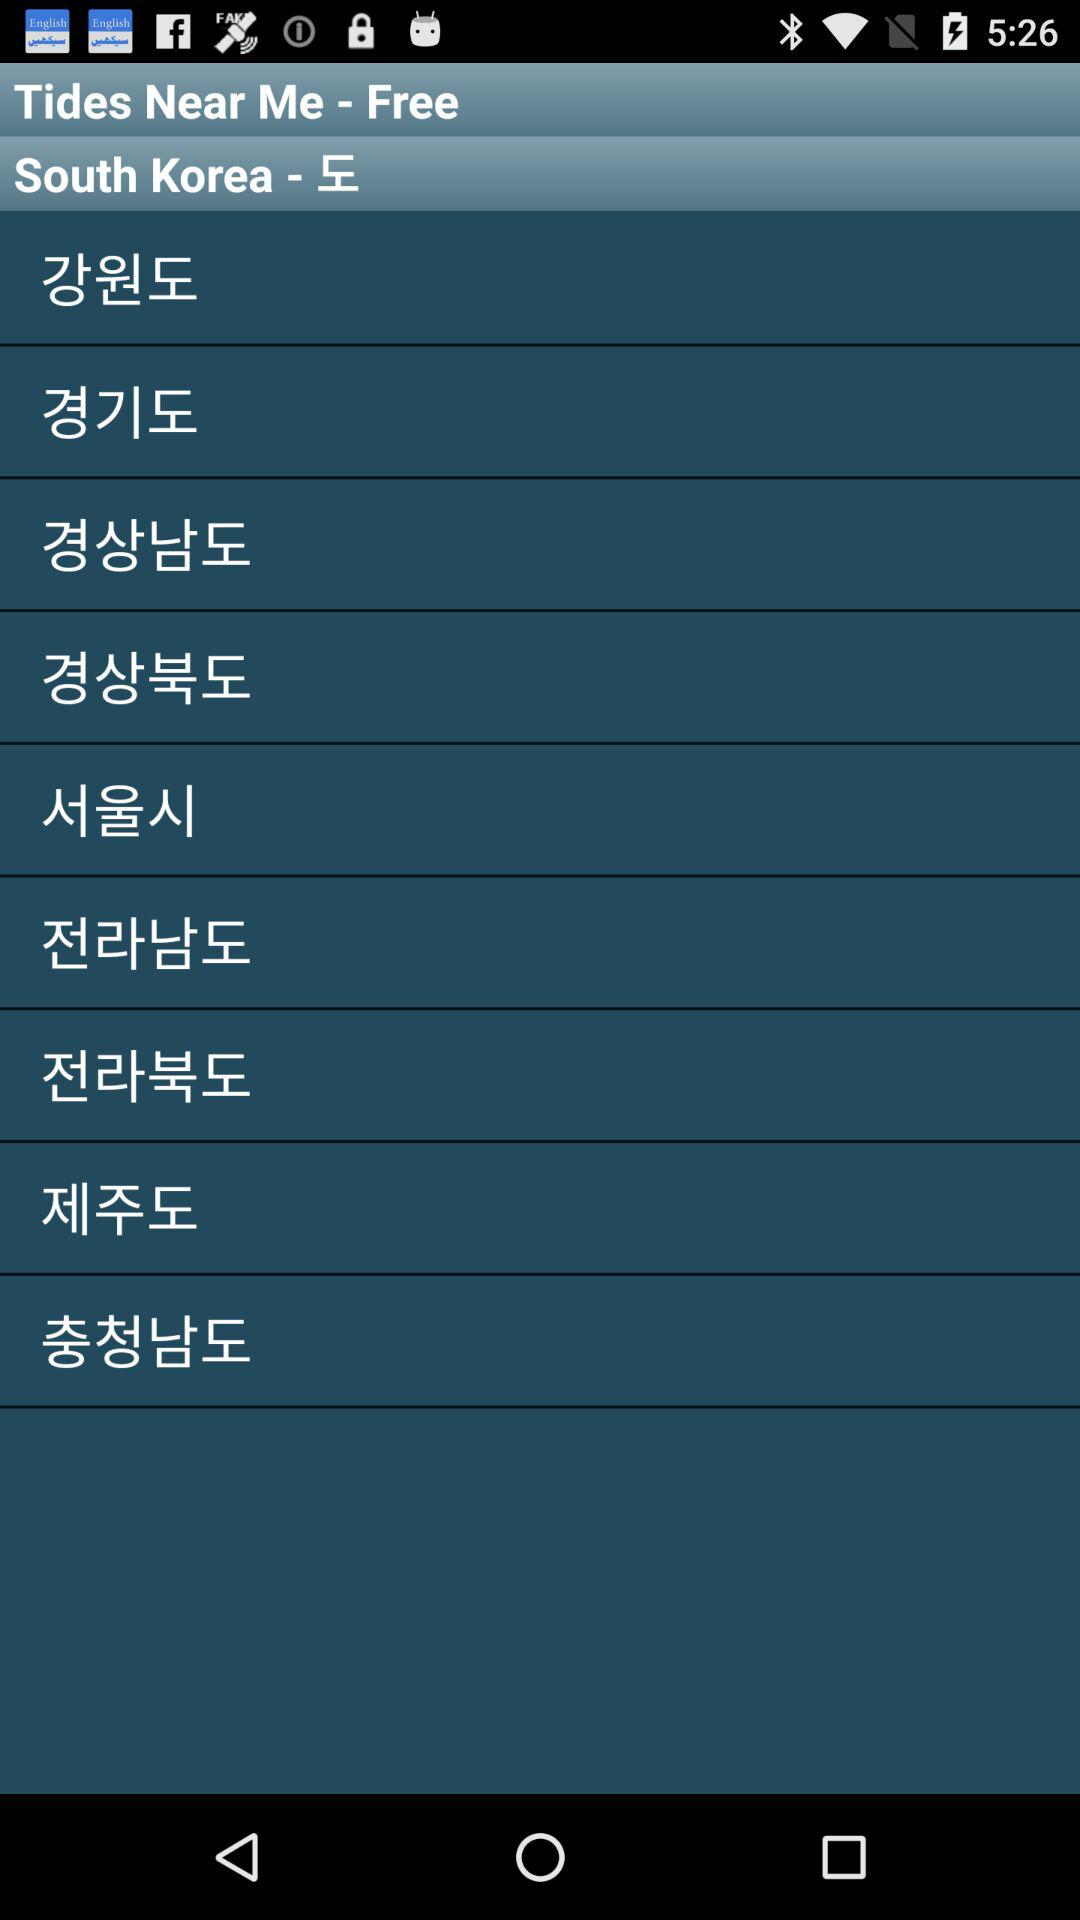How many provinces are there in South Korea?
Answer the question using a single word or phrase. 9 